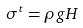<formula> <loc_0><loc_0><loc_500><loc_500>\sigma ^ { t } = \rho g H</formula> 